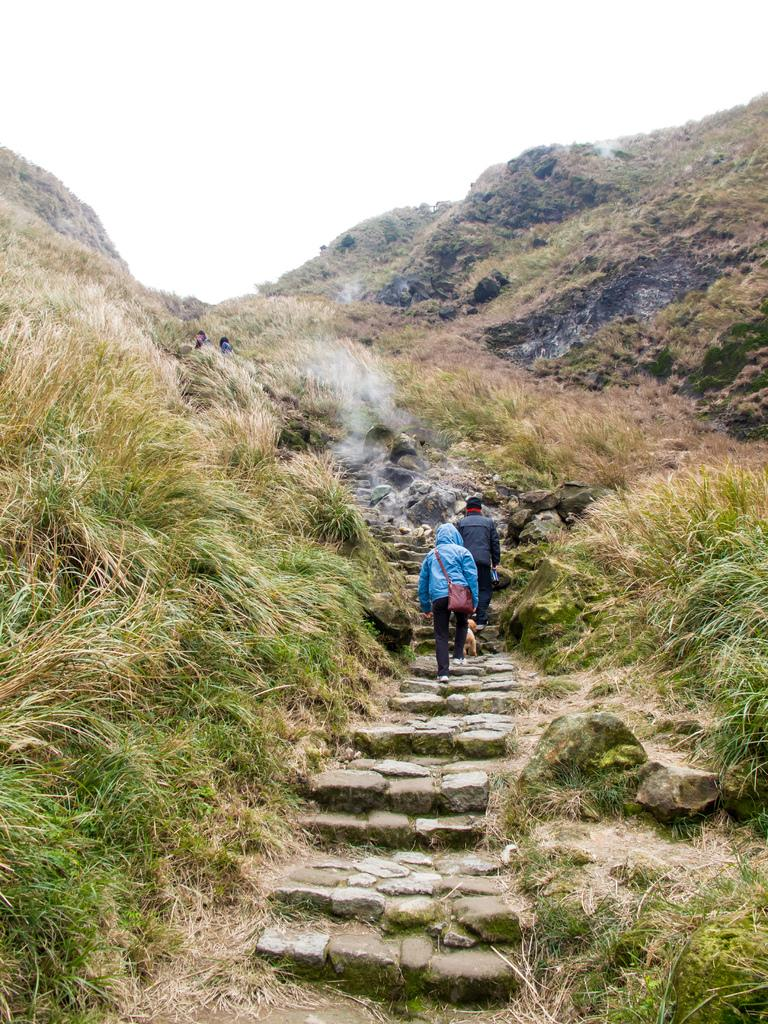How many people are walking in the image? There are two persons walking in the image. What are the persons walking on? The persons are walking through steps. What type of vegetation can be seen in the image? There are plants and grass present in the image. What is the weather like in the image? The presence of smoke suggests that there might be a fire or some form of activity causing smoke, but the weather cannot be determined solely from the image. What is the natural setting visible in the image? The natural setting includes hills and grass. What is visible at the top of the image? The sky is visible at the top of the image. What type of gate can be seen leading to the seashore in the image? There is no gate or seashore present in the image. What type of treatment is being administered to the plants in the image? There is no treatment being administered to the plants in the image; they are simply part of the natural setting. 